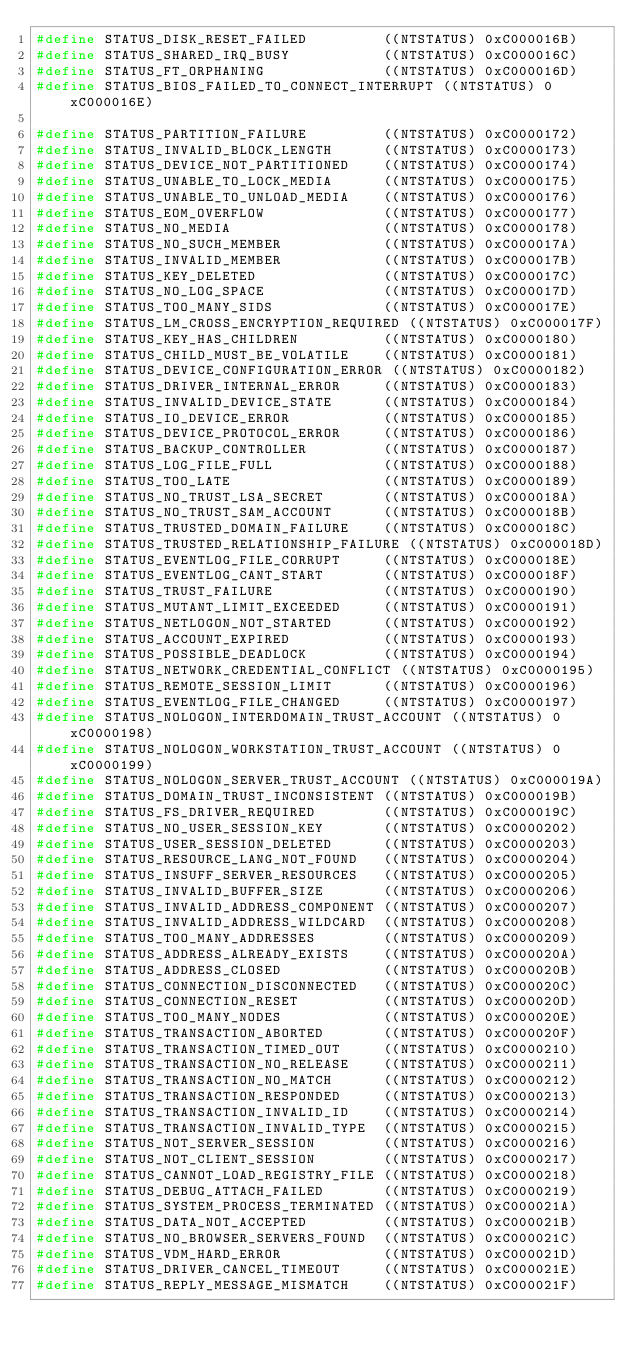Convert code to text. <code><loc_0><loc_0><loc_500><loc_500><_C_>#define STATUS_DISK_RESET_FAILED         ((NTSTATUS) 0xC000016B)
#define STATUS_SHARED_IRQ_BUSY           ((NTSTATUS) 0xC000016C)
#define STATUS_FT_ORPHANING              ((NTSTATUS) 0xC000016D)
#define STATUS_BIOS_FAILED_TO_CONNECT_INTERRUPT ((NTSTATUS) 0xC000016E)

#define STATUS_PARTITION_FAILURE         ((NTSTATUS) 0xC0000172)
#define STATUS_INVALID_BLOCK_LENGTH      ((NTSTATUS) 0xC0000173)
#define STATUS_DEVICE_NOT_PARTITIONED    ((NTSTATUS) 0xC0000174)
#define STATUS_UNABLE_TO_LOCK_MEDIA      ((NTSTATUS) 0xC0000175)
#define STATUS_UNABLE_TO_UNLOAD_MEDIA    ((NTSTATUS) 0xC0000176)
#define STATUS_EOM_OVERFLOW              ((NTSTATUS) 0xC0000177)
#define STATUS_NO_MEDIA                  ((NTSTATUS) 0xC0000178)
#define STATUS_NO_SUCH_MEMBER            ((NTSTATUS) 0xC000017A)
#define STATUS_INVALID_MEMBER            ((NTSTATUS) 0xC000017B)
#define STATUS_KEY_DELETED               ((NTSTATUS) 0xC000017C)
#define STATUS_NO_LOG_SPACE              ((NTSTATUS) 0xC000017D)
#define STATUS_TOO_MANY_SIDS             ((NTSTATUS) 0xC000017E)
#define STATUS_LM_CROSS_ENCRYPTION_REQUIRED ((NTSTATUS) 0xC000017F)
#define STATUS_KEY_HAS_CHILDREN          ((NTSTATUS) 0xC0000180)
#define STATUS_CHILD_MUST_BE_VOLATILE    ((NTSTATUS) 0xC0000181)
#define STATUS_DEVICE_CONFIGURATION_ERROR ((NTSTATUS) 0xC0000182)
#define STATUS_DRIVER_INTERNAL_ERROR     ((NTSTATUS) 0xC0000183)
#define STATUS_INVALID_DEVICE_STATE      ((NTSTATUS) 0xC0000184)
#define STATUS_IO_DEVICE_ERROR           ((NTSTATUS) 0xC0000185)
#define STATUS_DEVICE_PROTOCOL_ERROR     ((NTSTATUS) 0xC0000186)
#define STATUS_BACKUP_CONTROLLER         ((NTSTATUS) 0xC0000187)
#define STATUS_LOG_FILE_FULL             ((NTSTATUS) 0xC0000188)
#define STATUS_TOO_LATE                  ((NTSTATUS) 0xC0000189)
#define STATUS_NO_TRUST_LSA_SECRET       ((NTSTATUS) 0xC000018A)
#define STATUS_NO_TRUST_SAM_ACCOUNT      ((NTSTATUS) 0xC000018B)
#define STATUS_TRUSTED_DOMAIN_FAILURE    ((NTSTATUS) 0xC000018C)
#define STATUS_TRUSTED_RELATIONSHIP_FAILURE ((NTSTATUS) 0xC000018D)
#define STATUS_EVENTLOG_FILE_CORRUPT     ((NTSTATUS) 0xC000018E)
#define STATUS_EVENTLOG_CANT_START       ((NTSTATUS) 0xC000018F)
#define STATUS_TRUST_FAILURE             ((NTSTATUS) 0xC0000190)
#define STATUS_MUTANT_LIMIT_EXCEEDED     ((NTSTATUS) 0xC0000191)
#define STATUS_NETLOGON_NOT_STARTED      ((NTSTATUS) 0xC0000192)
#define STATUS_ACCOUNT_EXPIRED           ((NTSTATUS) 0xC0000193)
#define STATUS_POSSIBLE_DEADLOCK         ((NTSTATUS) 0xC0000194)
#define STATUS_NETWORK_CREDENTIAL_CONFLICT ((NTSTATUS) 0xC0000195)
#define STATUS_REMOTE_SESSION_LIMIT      ((NTSTATUS) 0xC0000196)
#define STATUS_EVENTLOG_FILE_CHANGED     ((NTSTATUS) 0xC0000197)
#define STATUS_NOLOGON_INTERDOMAIN_TRUST_ACCOUNT ((NTSTATUS) 0xC0000198)
#define STATUS_NOLOGON_WORKSTATION_TRUST_ACCOUNT ((NTSTATUS) 0xC0000199)
#define STATUS_NOLOGON_SERVER_TRUST_ACCOUNT ((NTSTATUS) 0xC000019A)
#define STATUS_DOMAIN_TRUST_INCONSISTENT ((NTSTATUS) 0xC000019B)
#define STATUS_FS_DRIVER_REQUIRED        ((NTSTATUS) 0xC000019C)
#define STATUS_NO_USER_SESSION_KEY       ((NTSTATUS) 0xC0000202)
#define STATUS_USER_SESSION_DELETED      ((NTSTATUS) 0xC0000203)
#define STATUS_RESOURCE_LANG_NOT_FOUND   ((NTSTATUS) 0xC0000204)
#define STATUS_INSUFF_SERVER_RESOURCES   ((NTSTATUS) 0xC0000205)
#define STATUS_INVALID_BUFFER_SIZE       ((NTSTATUS) 0xC0000206)
#define STATUS_INVALID_ADDRESS_COMPONENT ((NTSTATUS) 0xC0000207)
#define STATUS_INVALID_ADDRESS_WILDCARD  ((NTSTATUS) 0xC0000208)
#define STATUS_TOO_MANY_ADDRESSES        ((NTSTATUS) 0xC0000209)
#define STATUS_ADDRESS_ALREADY_EXISTS    ((NTSTATUS) 0xC000020A)
#define STATUS_ADDRESS_CLOSED            ((NTSTATUS) 0xC000020B)
#define STATUS_CONNECTION_DISCONNECTED   ((NTSTATUS) 0xC000020C)
#define STATUS_CONNECTION_RESET          ((NTSTATUS) 0xC000020D)
#define STATUS_TOO_MANY_NODES            ((NTSTATUS) 0xC000020E)
#define STATUS_TRANSACTION_ABORTED       ((NTSTATUS) 0xC000020F)
#define STATUS_TRANSACTION_TIMED_OUT     ((NTSTATUS) 0xC0000210)
#define STATUS_TRANSACTION_NO_RELEASE    ((NTSTATUS) 0xC0000211)
#define STATUS_TRANSACTION_NO_MATCH      ((NTSTATUS) 0xC0000212)
#define STATUS_TRANSACTION_RESPONDED     ((NTSTATUS) 0xC0000213)
#define STATUS_TRANSACTION_INVALID_ID    ((NTSTATUS) 0xC0000214)
#define STATUS_TRANSACTION_INVALID_TYPE  ((NTSTATUS) 0xC0000215)
#define STATUS_NOT_SERVER_SESSION        ((NTSTATUS) 0xC0000216)
#define STATUS_NOT_CLIENT_SESSION        ((NTSTATUS) 0xC0000217)
#define STATUS_CANNOT_LOAD_REGISTRY_FILE ((NTSTATUS) 0xC0000218)
#define STATUS_DEBUG_ATTACH_FAILED       ((NTSTATUS) 0xC0000219)
#define STATUS_SYSTEM_PROCESS_TERMINATED ((NTSTATUS) 0xC000021A)
#define STATUS_DATA_NOT_ACCEPTED         ((NTSTATUS) 0xC000021B)
#define STATUS_NO_BROWSER_SERVERS_FOUND  ((NTSTATUS) 0xC000021C)
#define STATUS_VDM_HARD_ERROR            ((NTSTATUS) 0xC000021D)
#define STATUS_DRIVER_CANCEL_TIMEOUT     ((NTSTATUS) 0xC000021E)
#define STATUS_REPLY_MESSAGE_MISMATCH    ((NTSTATUS) 0xC000021F)</code> 